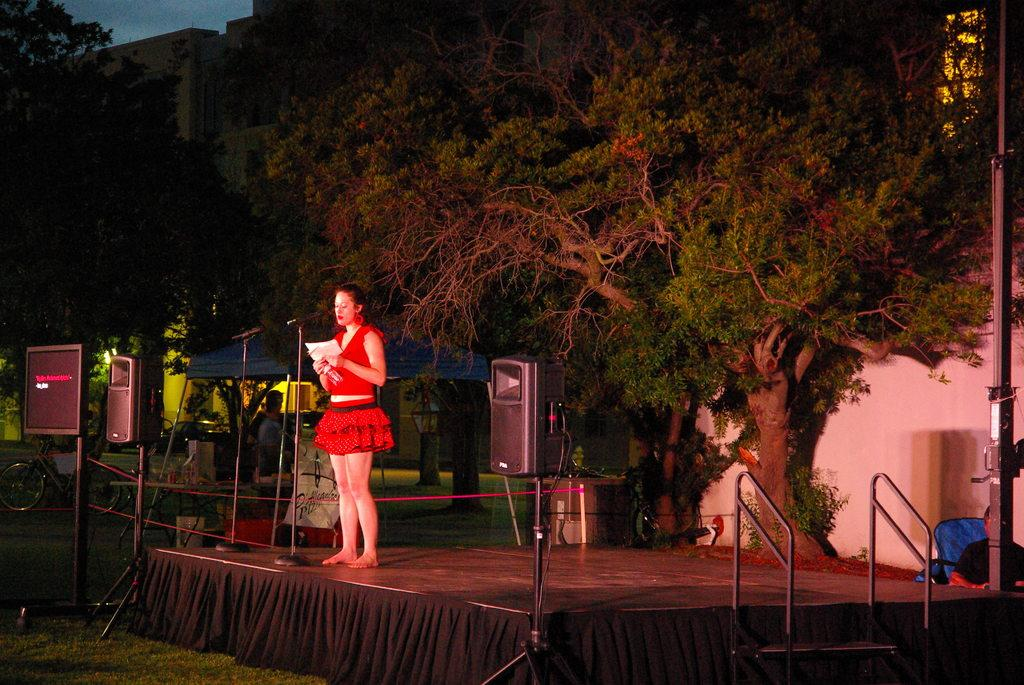What is the woman doing in the image? The woman is standing on a stage in the image. What is the woman holding in her hand? The woman is holding a paper in her hand. What is the woman likely to use to amplify her voice? There is a microphone in front of the woman, which she might use to amplify her voice. What can be seen in the background of the image? There are speakers and trees in the background of the image. What thoughts is the woman having while standing on the stage? We cannot determine the woman's thoughts from the image alone, as thoughts are not visible. 